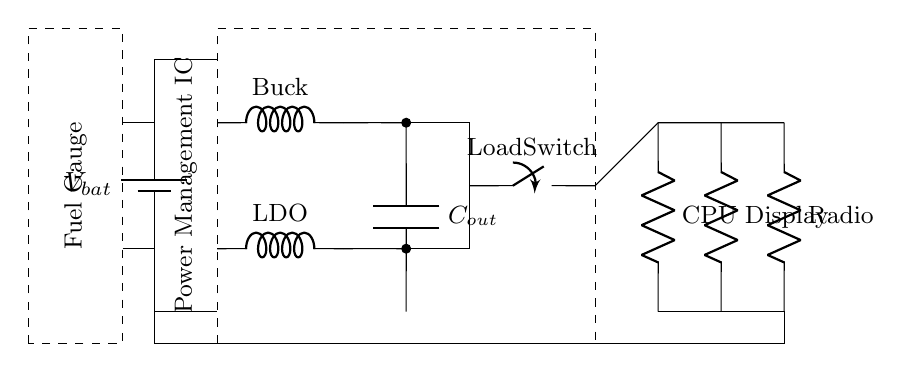What is the main function of the Power Management IC? The Power Management IC regulates the power distribution and ensures the efficient use of battery power among various components in the smartphone.
Answer: Power distribution What type of converter is used in this circuit? The circuit includes a Buck converter, which steps down the voltage for efficient power delivery.
Answer: Buck How many loads can this circuit accommodate? There are three loads specified in the diagram: CPU, Display, and Radio, which can all draw power from the Power Management IC.
Answer: Three What component is used to filter the output voltage? The output capacitor, labeled C out, is used to smooth and filter the voltage delivered to the load.
Answer: Output capacitor Why is a Load Switch used in this circuit? The Load Switch enables or disables the power supply to the loads, optimizing battery life by turning off components that are not in use.
Answer: To optimize battery life What would happen if the Buck converter failed? If the Buck converter failed, the battery voltage would not be regulated, potentially delivering too high a voltage to the loads and possibly damaging them.
Answer: Over-voltage damage What does the Fuel Gauge monitor? The Fuel Gauge tracks the battery's charge level, providing information on the remaining capacity and helping to manage power usage effectively.
Answer: Battery charge level 